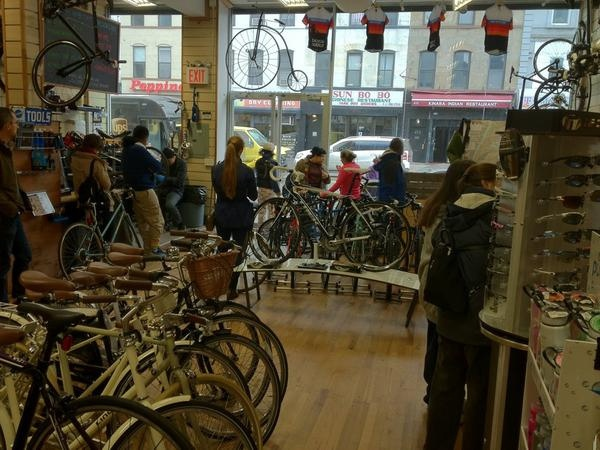Describe the objects in this image and their specific colors. I can see bicycle in maroon, black, and olive tones, people in maroon, black, and olive tones, bicycle in maroon, black, gray, and darkgreen tones, bicycle in maroon, black, olive, and gray tones, and bicycle in maroon, black, and gray tones in this image. 